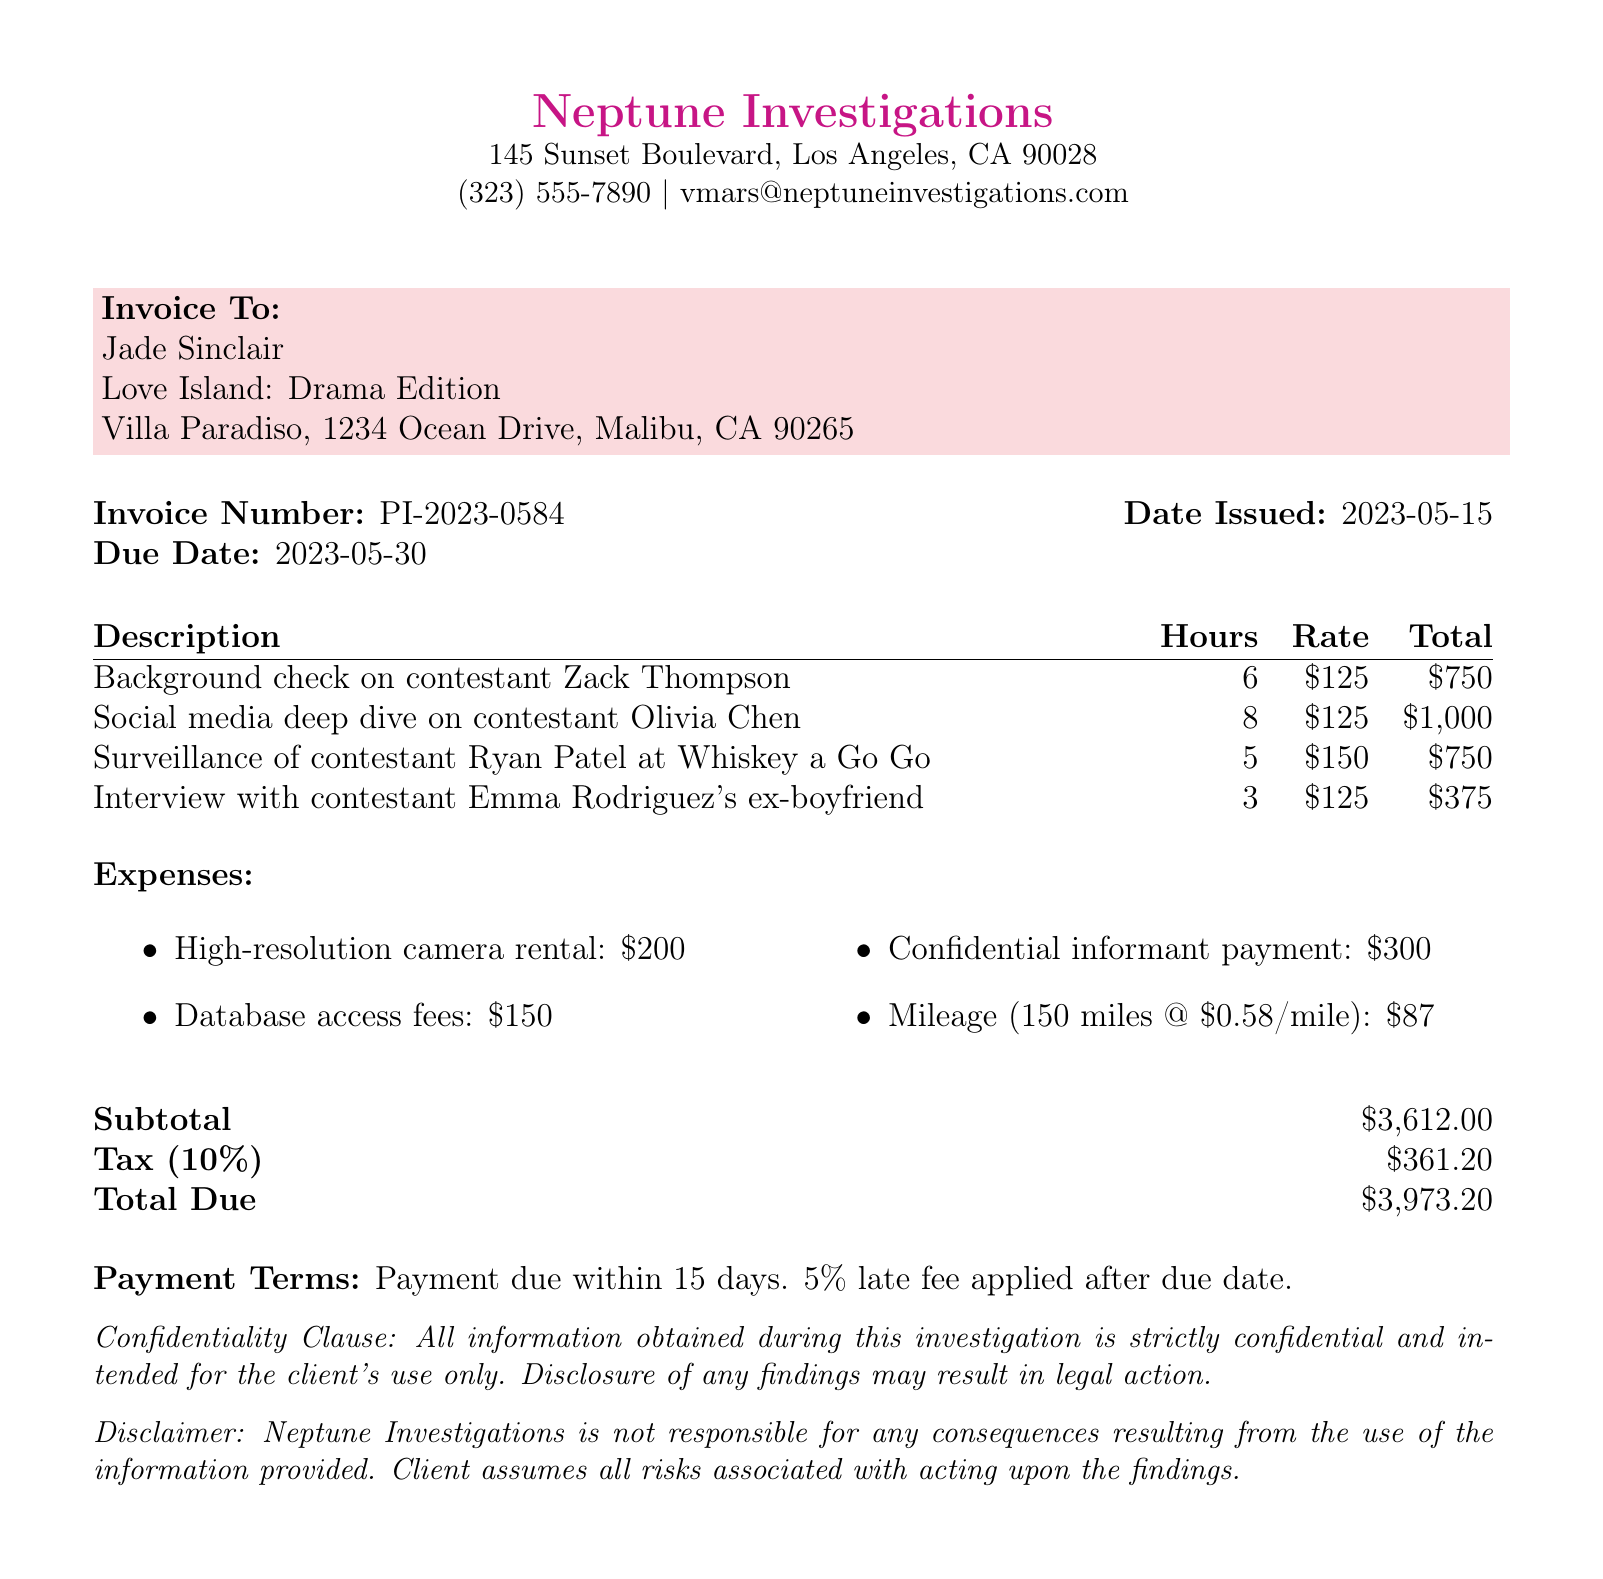What is the invoice number? The invoice number is listed at the top of the document as "PI-2023-0584".
Answer: PI-2023-0584 Who is the private investigator? The name of the private investigator is provided in the investigator details section as "Veronica Mars".
Answer: Veronica Mars What is the total amount due? The total amount due is calculated from the subtotal and tax, which totals $3,973.20 at the end of the document.
Answer: $3,973.20 How many hours were spent on the social media deep dive? The document states that 8 hours were spent on the social media deep dive on contestant Olivia Chen.
Answer: 8 hours What is the confidentiality clause about? The confidentiality clause emphasizes that all information obtained is strictly confidential and intended for the client's use only.
Answer: Strictly confidential What is the total number of services provided? The document lists four separate services performed for the client, indicating the number of services provided.
Answer: 4 What amount was charged for mileage? The mileage expense is specifically detailed in the expenses section and is listed as $87.
Answer: $87 What is the due date for the payment? The due date for payment is specified in the invoice details as "2023-05-30".
Answer: 2023-05-30 What is the late fee percentage applied after the due date? The payment terms state that a late fee of 5% is applied after the due date.
Answer: 5% 